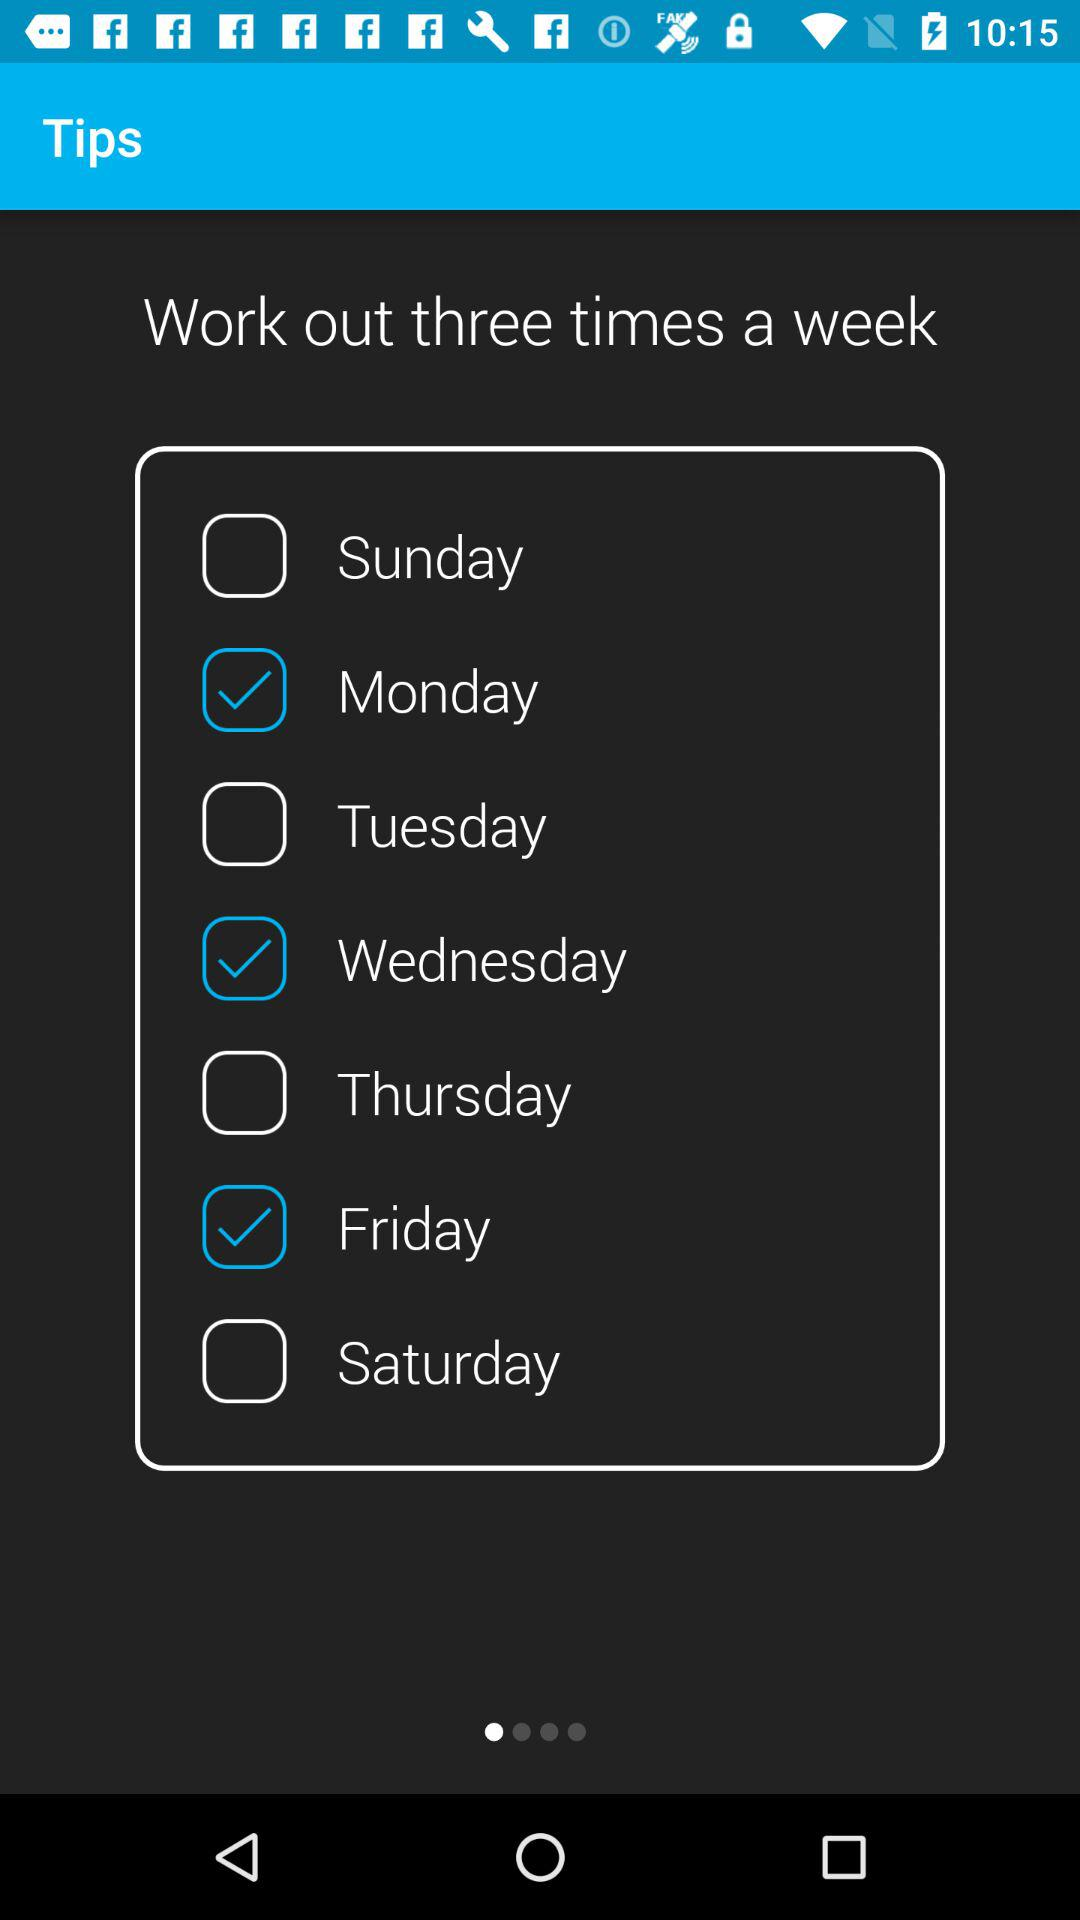What are the selected days for "Work out"? The selected days are "Monday", "Wednesday", and "Friday". 